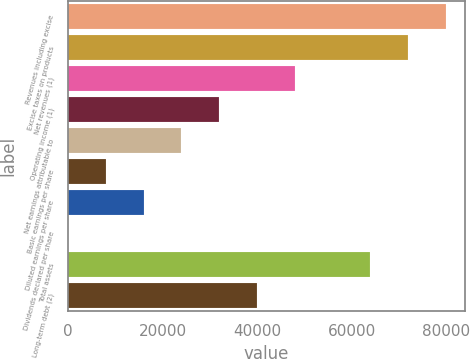<chart> <loc_0><loc_0><loc_500><loc_500><bar_chart><fcel>Revenues including excise<fcel>Excise taxes on products<fcel>Net revenues (1)<fcel>Operating income (1)<fcel>Net earnings attributable to<fcel>Basic earnings per share<fcel>Diluted earnings per share<fcel>Dividends declared per share<fcel>Total assets<fcel>Long-term debt (2)<nl><fcel>79823<fcel>71841.1<fcel>47895.6<fcel>31931.9<fcel>23950<fcel>7986.34<fcel>15968.2<fcel>4.49<fcel>63859.3<fcel>39913.7<nl></chart> 